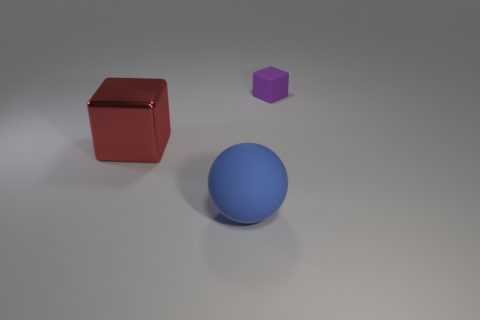Add 3 tiny cyan metallic balls. How many objects exist? 6 Subtract all red blocks. How many blocks are left? 1 Subtract 1 spheres. How many spheres are left? 0 Add 3 tiny red metallic blocks. How many tiny red metallic blocks exist? 3 Subtract 0 brown spheres. How many objects are left? 3 Subtract all spheres. How many objects are left? 2 Subtract all gray blocks. Subtract all blue cylinders. How many blocks are left? 2 Subtract all brown spheres. How many cyan blocks are left? 0 Subtract all large yellow blocks. Subtract all blue objects. How many objects are left? 2 Add 3 red metal things. How many red metal things are left? 4 